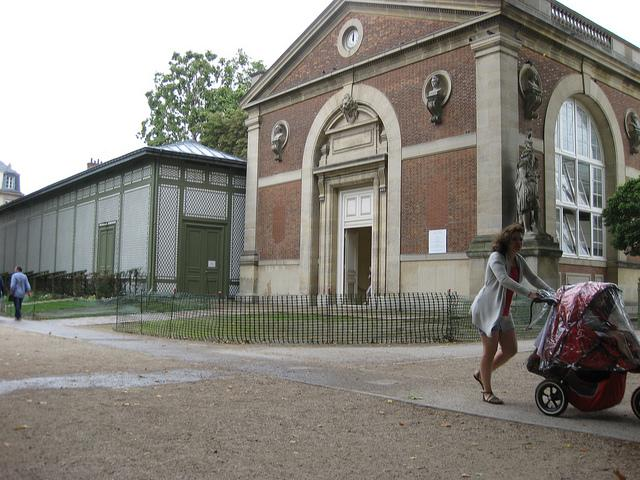What is the woman pushing? stroller 